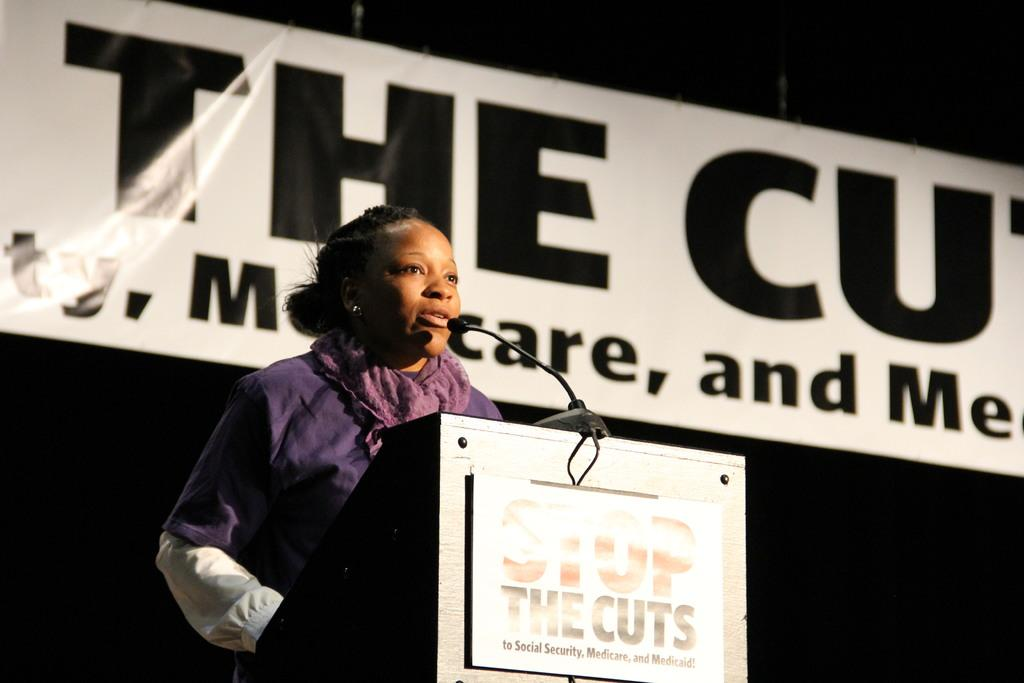Who is the main subject in the image? There is a woman in the image. What is the woman doing in the image? The woman is standing at a speech desk and giving a speech. What can be seen in the background of the image? There is a banner in the background of the image. What is the color pattern of the banner? The banner has a white and black color pattern. What type of science experiment is the woman conducting in the image? There is no science experiment present in the image; the woman is giving a speech. Can you tell me how many people the woman is fighting with in the image? There is no fight or any indication of conflict in the image; the woman is giving a speech. 